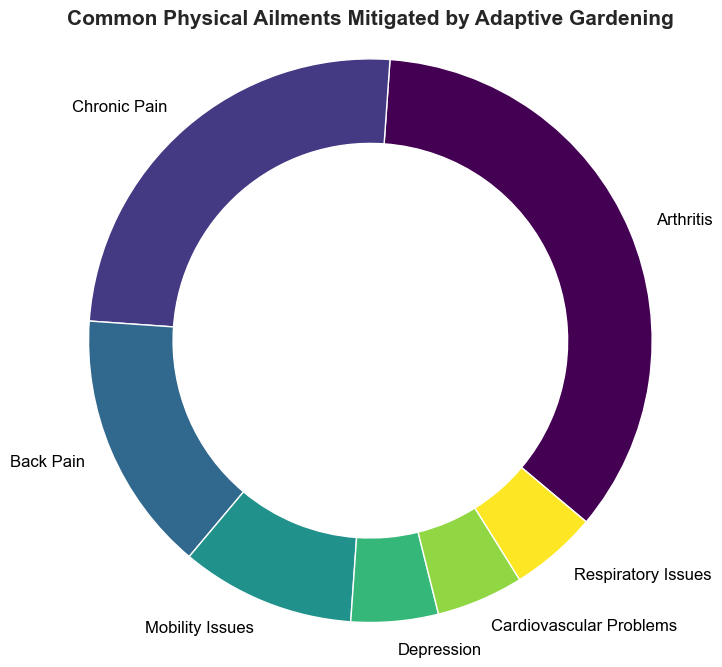what is the percentage of ailments related to physical pain (Arthritis, Chronic Pain, and Back Pain)? Add the percentages of Arthritis (35%), Chronic Pain (25%), and Back Pain (15%). So the total is 35 + 25 + 15 = 75%.
Answer: 75% Which ailment has the highest percentage? Look at the slices of the ring chart and see which ailment's label is associated with the largest segment. Arthritis has the largest segment with 35%.
Answer: Arthritis Which ailment has a larger percentage: Mobility Issues or Depression? Comparing the two segments' percentages: Mobility Issues is 10% and Depression is 5%. Hence, Mobility Issues has a larger percentage.
Answer: Mobility Issues How does the combined percentage of cardiovascular problems and respiratory issues compare to depression? Add the percentages of Cardiovascular Problems (5%) and Respiratory Issues (5%). Then compare the sum (10%) to Depression (5%). The combined percentage (10%) is greater than the percentage for Depression (5%).
Answer: The combined percentage is greater What is the total percentage of mental health-related ailments (Depression) and cardiovascular issues? Add the percentages of Depression (5%) and Cardiovascular Problems (5%). Total is 5 + 5 = 10%.
Answer: 10% Which percentage is represented by the second smallest segment and what is the associated ailment? Find the second smallest segment by visually comparing the sizes: The smallest is Depression (5%) and Respiratory Issues (also 5%), but these are tied. The next larger segment is Mobility Issues (10%).
Answer: Respiratory Issues and Cardiovascular Problems (both 5%) If you were to group ailments mitigated by adaptive gardening into those that affect the joints versus those that affect other parts of the body, what percentage of the chart represents joint-related issues (Arthritis)? Given 35% for Arthritis, that is the percentage exclusively related to joints.
Answer: 35% Consider the color gradients in the ring chart. Which ailment has the lightest (brightest) color, and why? The color scheme used typically assigns the lightest color to the first segment and the darkest to the last. Arthritis (35%) being the first segment has the lightest color.
Answer: Arthritis 